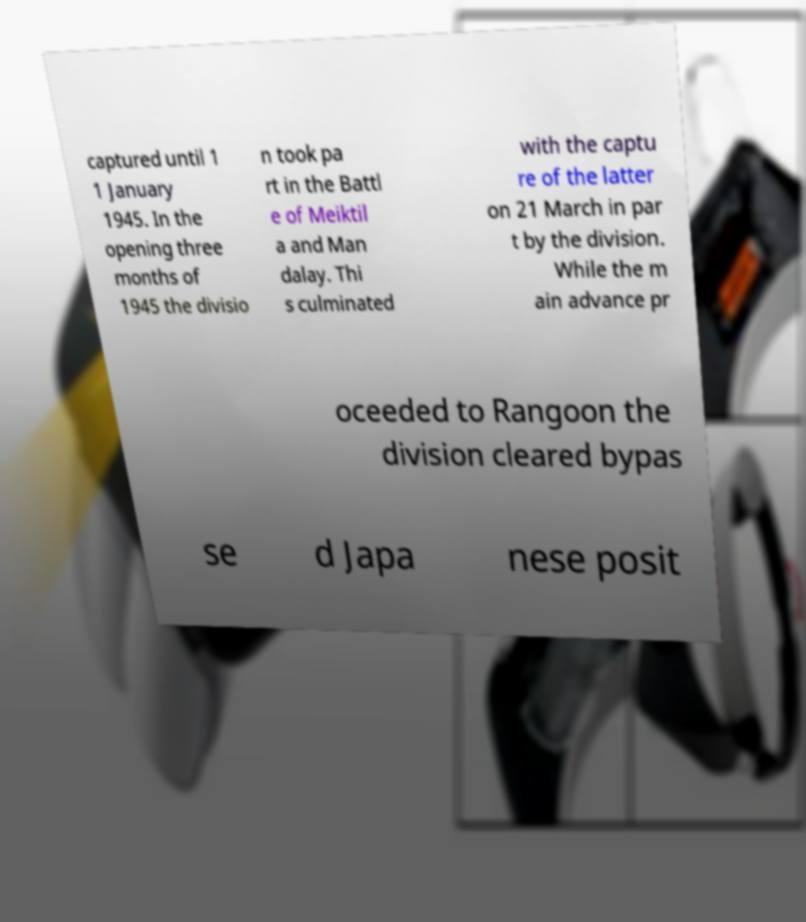For documentation purposes, I need the text within this image transcribed. Could you provide that? captured until 1 1 January 1945. In the opening three months of 1945 the divisio n took pa rt in the Battl e of Meiktil a and Man dalay. Thi s culminated with the captu re of the latter on 21 March in par t by the division. While the m ain advance pr oceeded to Rangoon the division cleared bypas se d Japa nese posit 